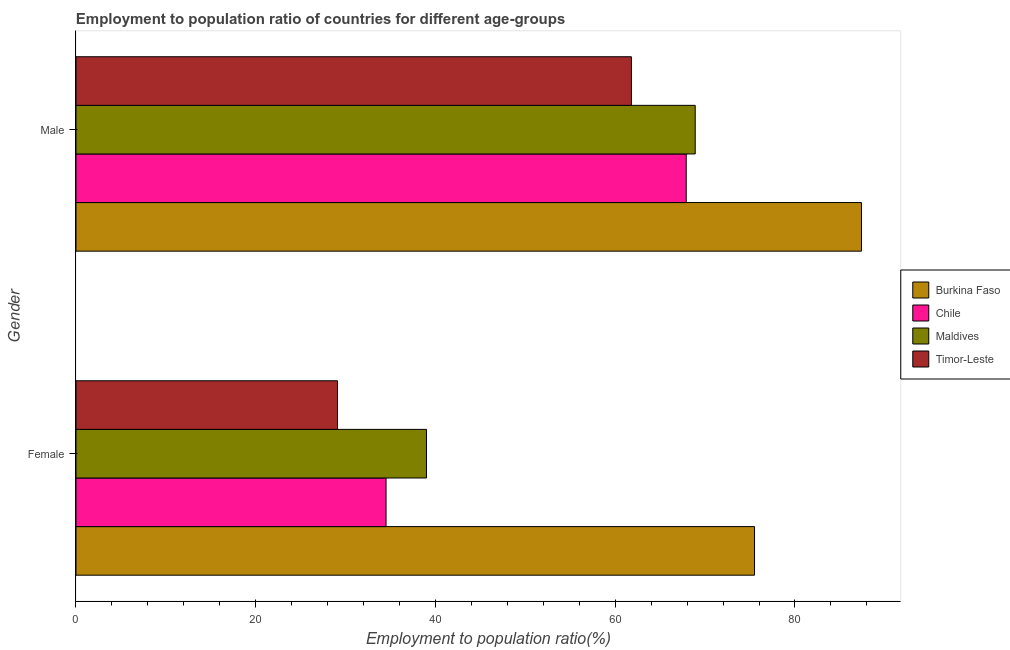Are the number of bars on each tick of the Y-axis equal?
Offer a very short reply. Yes. What is the label of the 2nd group of bars from the top?
Keep it short and to the point. Female. What is the employment to population ratio(female) in Chile?
Make the answer very short. 34.5. Across all countries, what is the maximum employment to population ratio(female)?
Ensure brevity in your answer.  75.5. Across all countries, what is the minimum employment to population ratio(female)?
Offer a very short reply. 29.1. In which country was the employment to population ratio(male) maximum?
Your answer should be compact. Burkina Faso. In which country was the employment to population ratio(male) minimum?
Ensure brevity in your answer.  Timor-Leste. What is the total employment to population ratio(female) in the graph?
Keep it short and to the point. 178.1. What is the difference between the employment to population ratio(male) in Timor-Leste and that in Burkina Faso?
Your answer should be compact. -25.6. What is the difference between the employment to population ratio(male) in Timor-Leste and the employment to population ratio(female) in Maldives?
Your answer should be compact. 22.8. What is the average employment to population ratio(male) per country?
Offer a very short reply. 71.5. What is the difference between the employment to population ratio(female) and employment to population ratio(male) in Timor-Leste?
Offer a very short reply. -32.7. In how many countries, is the employment to population ratio(male) greater than 64 %?
Provide a short and direct response. 3. What is the ratio of the employment to population ratio(female) in Chile to that in Burkina Faso?
Provide a succinct answer. 0.46. In how many countries, is the employment to population ratio(male) greater than the average employment to population ratio(male) taken over all countries?
Give a very brief answer. 1. What does the 4th bar from the top in Female represents?
Offer a terse response. Burkina Faso. What does the 1st bar from the bottom in Female represents?
Give a very brief answer. Burkina Faso. How many bars are there?
Ensure brevity in your answer.  8. What is the difference between two consecutive major ticks on the X-axis?
Make the answer very short. 20. Does the graph contain any zero values?
Provide a succinct answer. No. Where does the legend appear in the graph?
Ensure brevity in your answer.  Center right. How many legend labels are there?
Make the answer very short. 4. How are the legend labels stacked?
Your answer should be very brief. Vertical. What is the title of the graph?
Keep it short and to the point. Employment to population ratio of countries for different age-groups. What is the label or title of the X-axis?
Your response must be concise. Employment to population ratio(%). What is the label or title of the Y-axis?
Your response must be concise. Gender. What is the Employment to population ratio(%) in Burkina Faso in Female?
Your response must be concise. 75.5. What is the Employment to population ratio(%) in Chile in Female?
Give a very brief answer. 34.5. What is the Employment to population ratio(%) in Maldives in Female?
Offer a terse response. 39. What is the Employment to population ratio(%) in Timor-Leste in Female?
Offer a very short reply. 29.1. What is the Employment to population ratio(%) in Burkina Faso in Male?
Provide a succinct answer. 87.4. What is the Employment to population ratio(%) of Chile in Male?
Provide a short and direct response. 67.9. What is the Employment to population ratio(%) of Maldives in Male?
Make the answer very short. 68.9. What is the Employment to population ratio(%) of Timor-Leste in Male?
Your answer should be very brief. 61.8. Across all Gender, what is the maximum Employment to population ratio(%) in Burkina Faso?
Provide a short and direct response. 87.4. Across all Gender, what is the maximum Employment to population ratio(%) in Chile?
Offer a very short reply. 67.9. Across all Gender, what is the maximum Employment to population ratio(%) of Maldives?
Provide a succinct answer. 68.9. Across all Gender, what is the maximum Employment to population ratio(%) in Timor-Leste?
Provide a succinct answer. 61.8. Across all Gender, what is the minimum Employment to population ratio(%) of Burkina Faso?
Your answer should be very brief. 75.5. Across all Gender, what is the minimum Employment to population ratio(%) in Chile?
Ensure brevity in your answer.  34.5. Across all Gender, what is the minimum Employment to population ratio(%) in Timor-Leste?
Your answer should be compact. 29.1. What is the total Employment to population ratio(%) of Burkina Faso in the graph?
Your response must be concise. 162.9. What is the total Employment to population ratio(%) of Chile in the graph?
Give a very brief answer. 102.4. What is the total Employment to population ratio(%) of Maldives in the graph?
Offer a very short reply. 107.9. What is the total Employment to population ratio(%) of Timor-Leste in the graph?
Provide a succinct answer. 90.9. What is the difference between the Employment to population ratio(%) in Burkina Faso in Female and that in Male?
Keep it short and to the point. -11.9. What is the difference between the Employment to population ratio(%) of Chile in Female and that in Male?
Your answer should be very brief. -33.4. What is the difference between the Employment to population ratio(%) in Maldives in Female and that in Male?
Provide a short and direct response. -29.9. What is the difference between the Employment to population ratio(%) in Timor-Leste in Female and that in Male?
Provide a succinct answer. -32.7. What is the difference between the Employment to population ratio(%) of Burkina Faso in Female and the Employment to population ratio(%) of Chile in Male?
Provide a succinct answer. 7.6. What is the difference between the Employment to population ratio(%) in Burkina Faso in Female and the Employment to population ratio(%) in Maldives in Male?
Provide a succinct answer. 6.6. What is the difference between the Employment to population ratio(%) of Burkina Faso in Female and the Employment to population ratio(%) of Timor-Leste in Male?
Keep it short and to the point. 13.7. What is the difference between the Employment to population ratio(%) of Chile in Female and the Employment to population ratio(%) of Maldives in Male?
Provide a succinct answer. -34.4. What is the difference between the Employment to population ratio(%) in Chile in Female and the Employment to population ratio(%) in Timor-Leste in Male?
Offer a terse response. -27.3. What is the difference between the Employment to population ratio(%) of Maldives in Female and the Employment to population ratio(%) of Timor-Leste in Male?
Provide a succinct answer. -22.8. What is the average Employment to population ratio(%) of Burkina Faso per Gender?
Offer a terse response. 81.45. What is the average Employment to population ratio(%) in Chile per Gender?
Offer a very short reply. 51.2. What is the average Employment to population ratio(%) of Maldives per Gender?
Give a very brief answer. 53.95. What is the average Employment to population ratio(%) of Timor-Leste per Gender?
Provide a short and direct response. 45.45. What is the difference between the Employment to population ratio(%) of Burkina Faso and Employment to population ratio(%) of Maldives in Female?
Make the answer very short. 36.5. What is the difference between the Employment to population ratio(%) of Burkina Faso and Employment to population ratio(%) of Timor-Leste in Female?
Give a very brief answer. 46.4. What is the difference between the Employment to population ratio(%) of Burkina Faso and Employment to population ratio(%) of Maldives in Male?
Your response must be concise. 18.5. What is the difference between the Employment to population ratio(%) of Burkina Faso and Employment to population ratio(%) of Timor-Leste in Male?
Offer a very short reply. 25.6. What is the difference between the Employment to population ratio(%) in Chile and Employment to population ratio(%) in Timor-Leste in Male?
Your answer should be compact. 6.1. What is the ratio of the Employment to population ratio(%) of Burkina Faso in Female to that in Male?
Your response must be concise. 0.86. What is the ratio of the Employment to population ratio(%) of Chile in Female to that in Male?
Ensure brevity in your answer.  0.51. What is the ratio of the Employment to population ratio(%) in Maldives in Female to that in Male?
Give a very brief answer. 0.57. What is the ratio of the Employment to population ratio(%) in Timor-Leste in Female to that in Male?
Your answer should be compact. 0.47. What is the difference between the highest and the second highest Employment to population ratio(%) in Chile?
Your answer should be very brief. 33.4. What is the difference between the highest and the second highest Employment to population ratio(%) of Maldives?
Offer a very short reply. 29.9. What is the difference between the highest and the second highest Employment to population ratio(%) of Timor-Leste?
Offer a terse response. 32.7. What is the difference between the highest and the lowest Employment to population ratio(%) of Burkina Faso?
Give a very brief answer. 11.9. What is the difference between the highest and the lowest Employment to population ratio(%) in Chile?
Your response must be concise. 33.4. What is the difference between the highest and the lowest Employment to population ratio(%) of Maldives?
Offer a terse response. 29.9. What is the difference between the highest and the lowest Employment to population ratio(%) of Timor-Leste?
Provide a succinct answer. 32.7. 